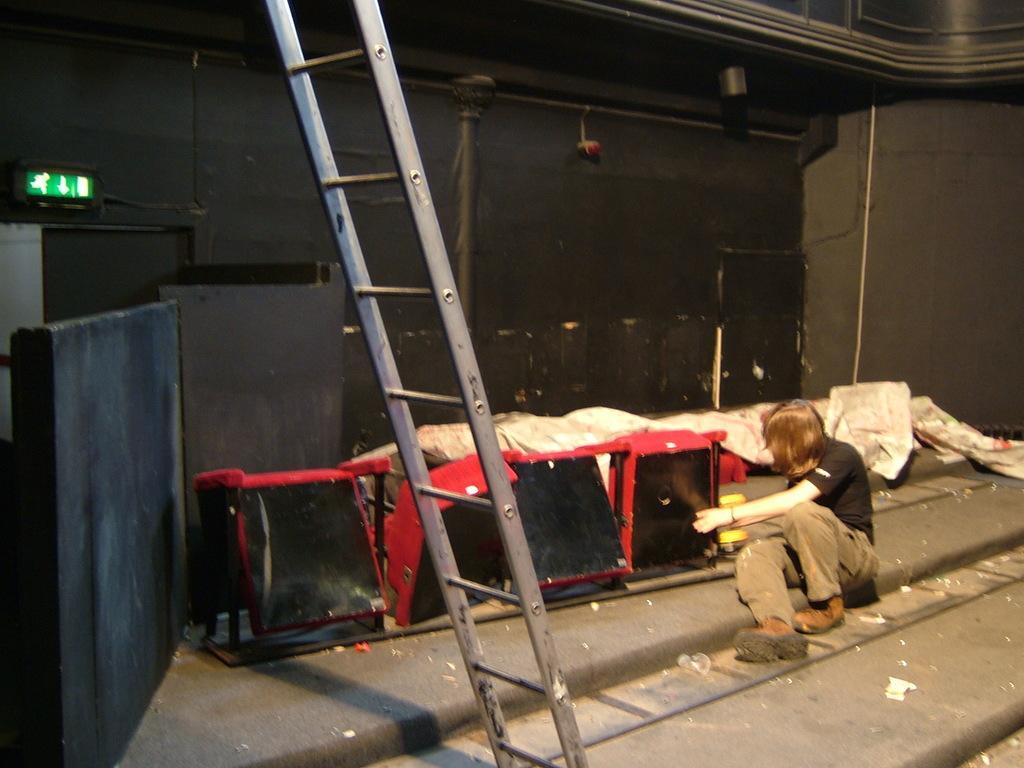Could you give a brief overview of what you see in this image? In this image we can see a person sitting on the floor, also we can see a ladder, signboard and some other objects, in the background, we can see the wall. 